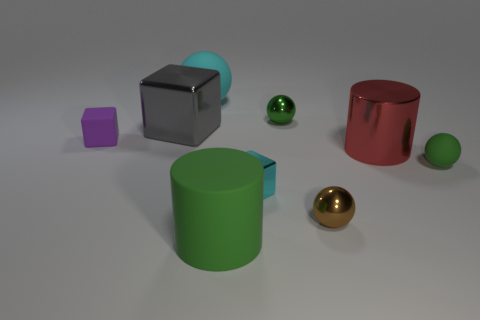Does the rubber block have the same size as the cube that is on the right side of the large green rubber cylinder?
Provide a succinct answer. Yes. What size is the red thing?
Make the answer very short. Large. What is the color of the tiny sphere that is the same material as the small brown thing?
Your response must be concise. Green. How many tiny blocks are made of the same material as the big sphere?
Ensure brevity in your answer.  1. How many things are purple cubes or metal objects that are behind the small brown metal ball?
Your answer should be compact. 5. Is the material of the tiny object to the left of the big cyan thing the same as the big green object?
Provide a short and direct response. Yes. The metal ball that is the same size as the green shiny object is what color?
Offer a terse response. Brown. Are there any other things of the same shape as the brown thing?
Offer a very short reply. Yes. There is a tiny matte thing left of the large metal object that is right of the big cyan rubber thing that is right of the tiny purple block; what color is it?
Make the answer very short. Purple. What number of shiny objects are small objects or big cyan blocks?
Offer a terse response. 3. 